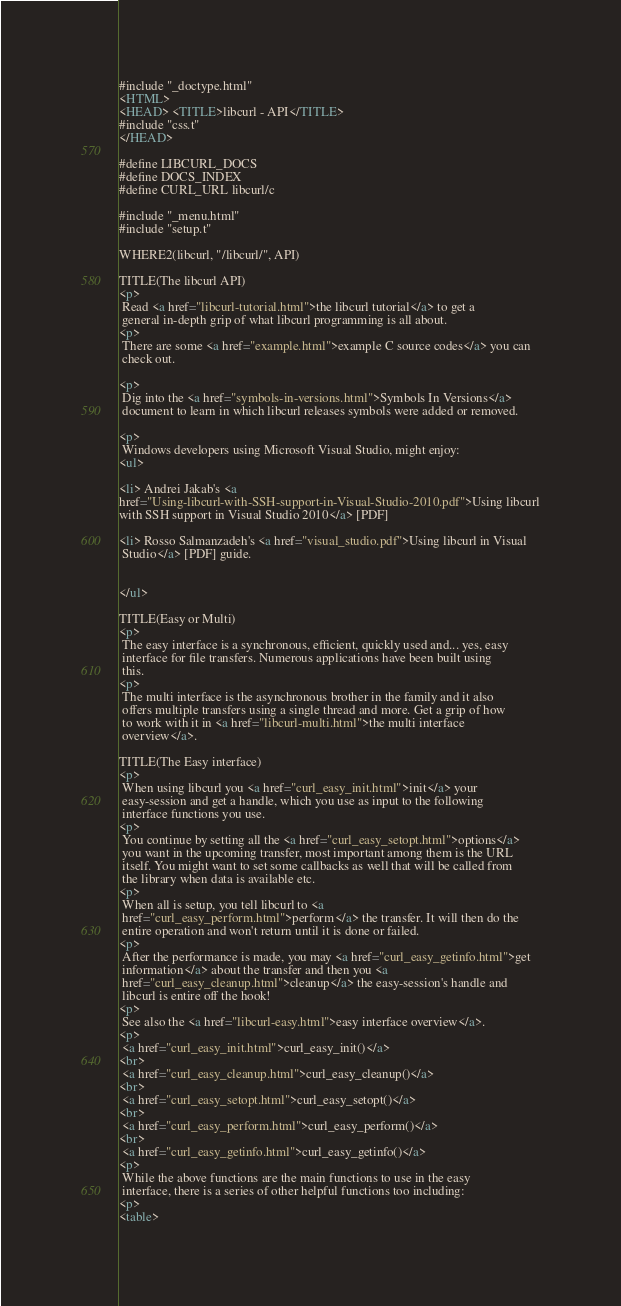<code> <loc_0><loc_0><loc_500><loc_500><_HTML_>#include "_doctype.html"
<HTML>
<HEAD> <TITLE>libcurl - API</TITLE>
#include "css.t"
</HEAD>

#define LIBCURL_DOCS
#define DOCS_INDEX
#define CURL_URL libcurl/c

#include "_menu.html"
#include "setup.t"

WHERE2(libcurl, "/libcurl/", API)

TITLE(The libcurl API)
<p>
 Read <a href="libcurl-tutorial.html">the libcurl tutorial</a> to get a
 general in-depth grip of what libcurl programming is all about.
<p>
 There are some <a href="example.html">example C source codes</a> you can
 check out.

<p>
 Dig into the <a href="symbols-in-versions.html">Symbols In Versions</a>
 document to learn in which libcurl releases symbols were added or removed.

<p>
 Windows developers using Microsoft Visual Studio, might enjoy:
<ul>

<li> Andrei Jakab's <a
href="Using-libcurl-with-SSH-support-in-Visual-Studio-2010.pdf">Using libcurl
with SSH support in Visual Studio 2010</a> [PDF]

<li> Rosso Salmanzadeh's <a href="visual_studio.pdf">Using libcurl in Visual
 Studio</a> [PDF] guide.


</ul>

TITLE(Easy or Multi)
<p>
 The easy interface is a synchronous, efficient, quickly used and... yes, easy
 interface for file transfers. Numerous applications have been built using
 this.
<p>
 The multi interface is the asynchronous brother in the family and it also
 offers multiple transfers using a single thread and more. Get a grip of how
 to work with it in <a href="libcurl-multi.html">the multi interface
 overview</a>.

TITLE(The Easy interface)
<p>
 When using libcurl you <a href="curl_easy_init.html">init</a> your
 easy-session and get a handle, which you use as input to the following
 interface functions you use.
<p>
 You continue by setting all the <a href="curl_easy_setopt.html">options</a>
 you want in the upcoming transfer, most important among them is the URL
 itself. You might want to set some callbacks as well that will be called from
 the library when data is available etc.
<p>
 When all is setup, you tell libcurl to <a
 href="curl_easy_perform.html">perform</a> the transfer. It will then do the
 entire operation and won't return until it is done or failed.
<p>
 After the performance is made, you may <a href="curl_easy_getinfo.html">get
 information</a> about the transfer and then you <a
 href="curl_easy_cleanup.html">cleanup</a> the easy-session's handle and
 libcurl is entire off the hook!
<p>
 See also the <a href="libcurl-easy.html">easy interface overview</a>. 
<p>
 <a href="curl_easy_init.html">curl_easy_init()</a>
<br>
 <a href="curl_easy_cleanup.html">curl_easy_cleanup()</a>
<br>
 <a href="curl_easy_setopt.html">curl_easy_setopt()</a>
<br>
 <a href="curl_easy_perform.html">curl_easy_perform()</a>
<br>
 <a href="curl_easy_getinfo.html">curl_easy_getinfo()</a>
<p>
 While the above functions are the main functions to use in the easy
 interface, there is a series of other helpful functions too including:
<p>
<table></code> 